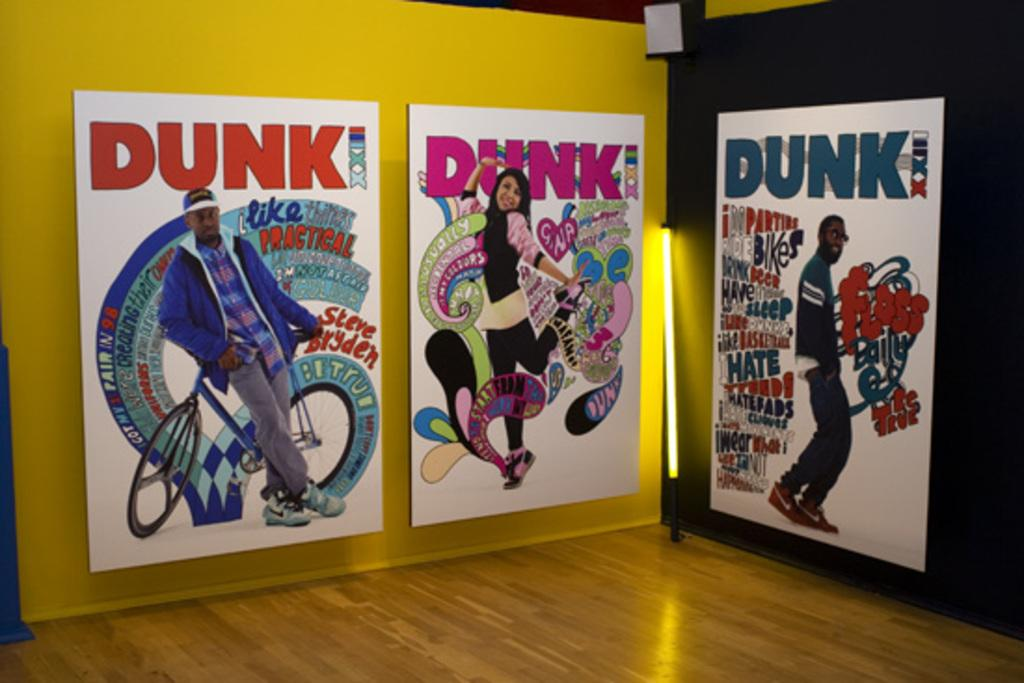<image>
Create a compact narrative representing the image presented. large posters on the wall that are each titled 'dunk' 